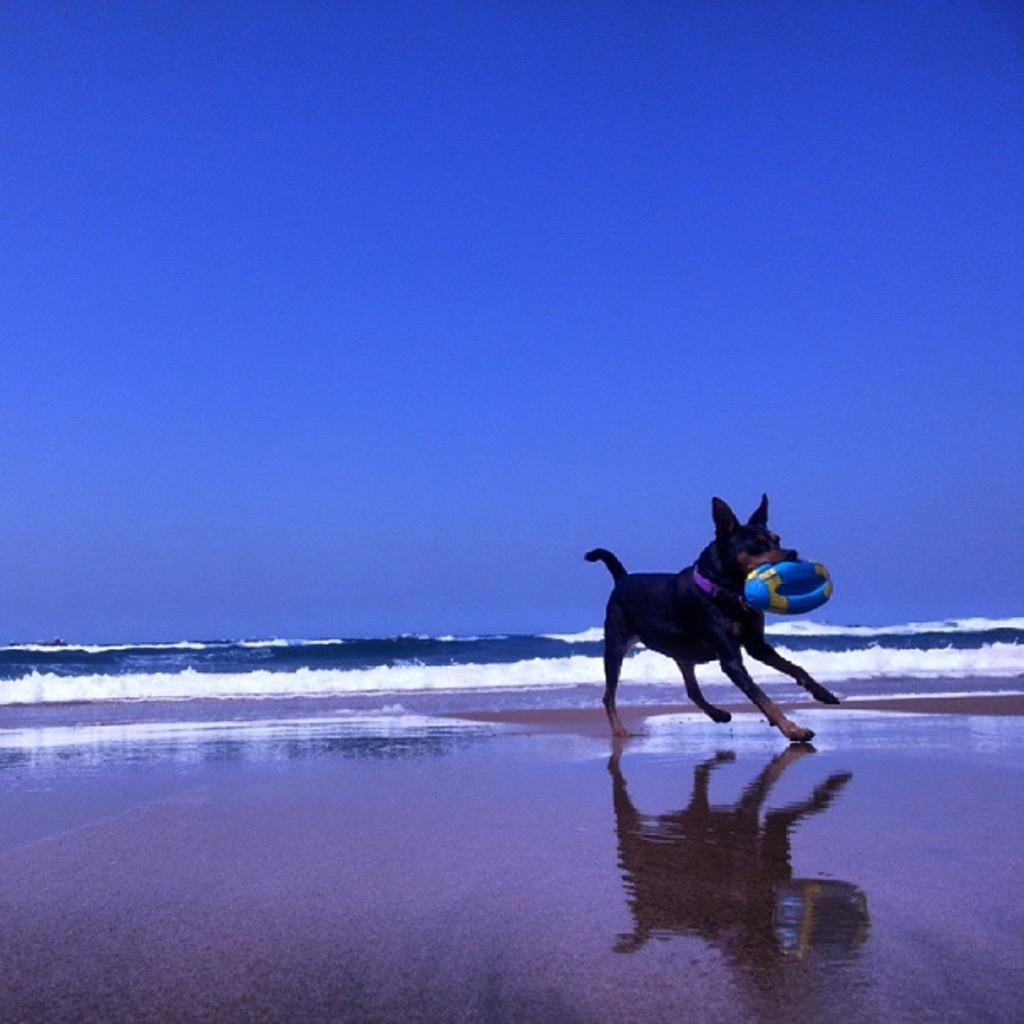What is the main object in the center of the image? There is a ball in the center of the image. What animal is present in the image? There is a dog in the image. Where is the dog located in the image? The dog is at the sea shore. What can be seen in the background of the image? There is water and the sky visible in the background of the image. What type of bird can be seen flying over the yard in the image? There is no bird or yard present in the image; it features a ball, a dog, and the sea shore. 